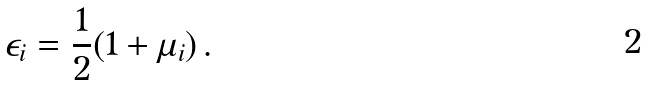Convert formula to latex. <formula><loc_0><loc_0><loc_500><loc_500>\epsilon _ { i } = \frac { 1 } { 2 } ( 1 + \mu _ { i } ) \, .</formula> 